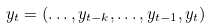<formula> <loc_0><loc_0><loc_500><loc_500>y _ { t } = ( \dots , y _ { t - k } , \dots , y _ { t - 1 } , y _ { t } )</formula> 